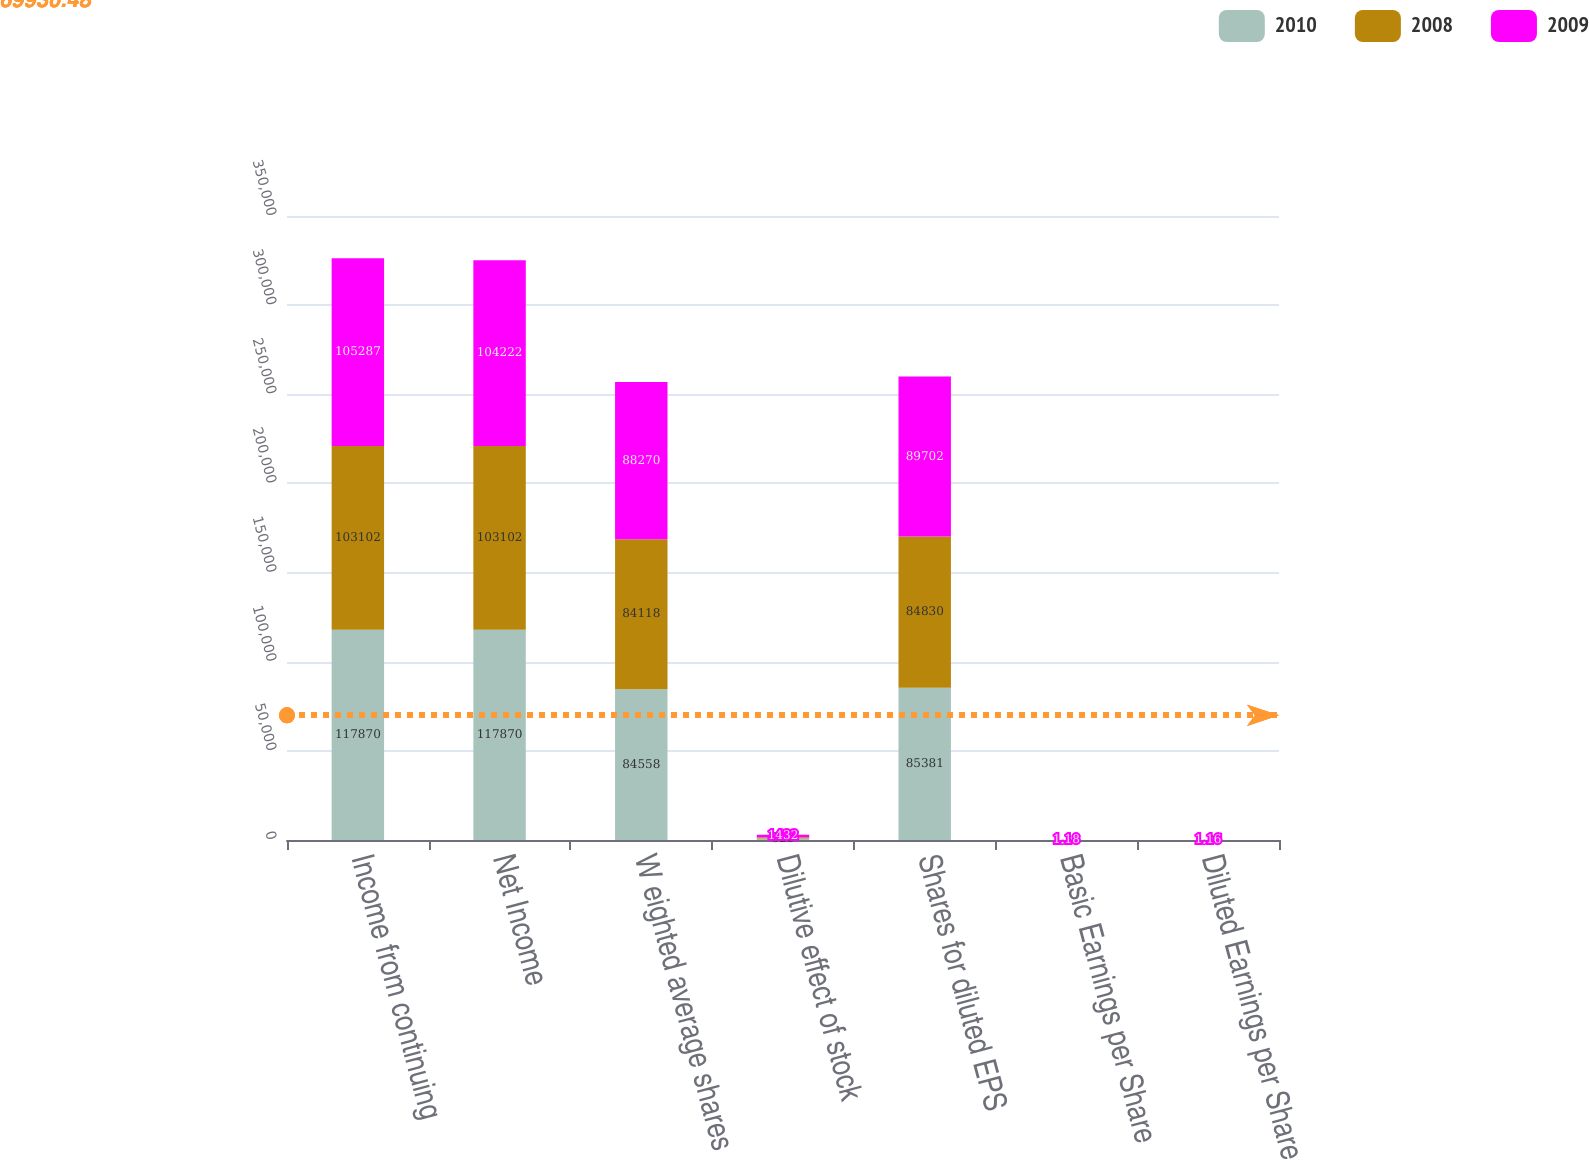Convert chart. <chart><loc_0><loc_0><loc_500><loc_500><stacked_bar_chart><ecel><fcel>Income from continuing<fcel>Net Income<fcel>W eighted average shares<fcel>Dilutive effect of stock<fcel>Shares for diluted EPS<fcel>Basic Earnings per Share<fcel>Diluted Earnings per Share<nl><fcel>2010<fcel>117870<fcel>117870<fcel>84558<fcel>823<fcel>85381<fcel>1.39<fcel>1.38<nl><fcel>2008<fcel>103102<fcel>103102<fcel>84118<fcel>712<fcel>84830<fcel>1.23<fcel>1.22<nl><fcel>2009<fcel>105287<fcel>104222<fcel>88270<fcel>1432<fcel>89702<fcel>1.18<fcel>1.16<nl></chart> 